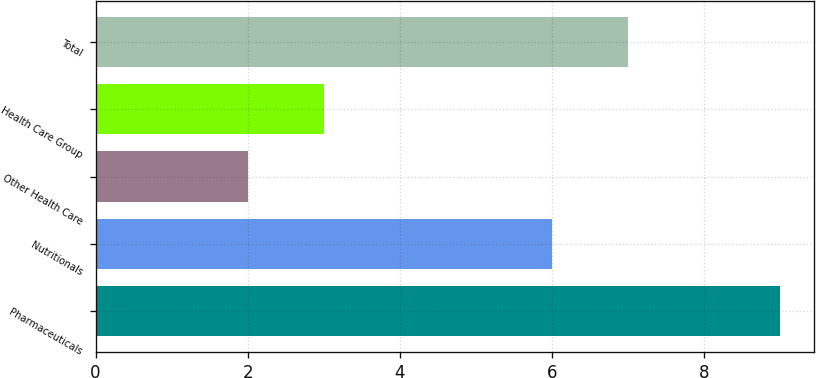Convert chart. <chart><loc_0><loc_0><loc_500><loc_500><bar_chart><fcel>Pharmaceuticals<fcel>Nutritionals<fcel>Other Health Care<fcel>Health Care Group<fcel>Total<nl><fcel>9<fcel>6<fcel>2<fcel>3<fcel>7<nl></chart> 